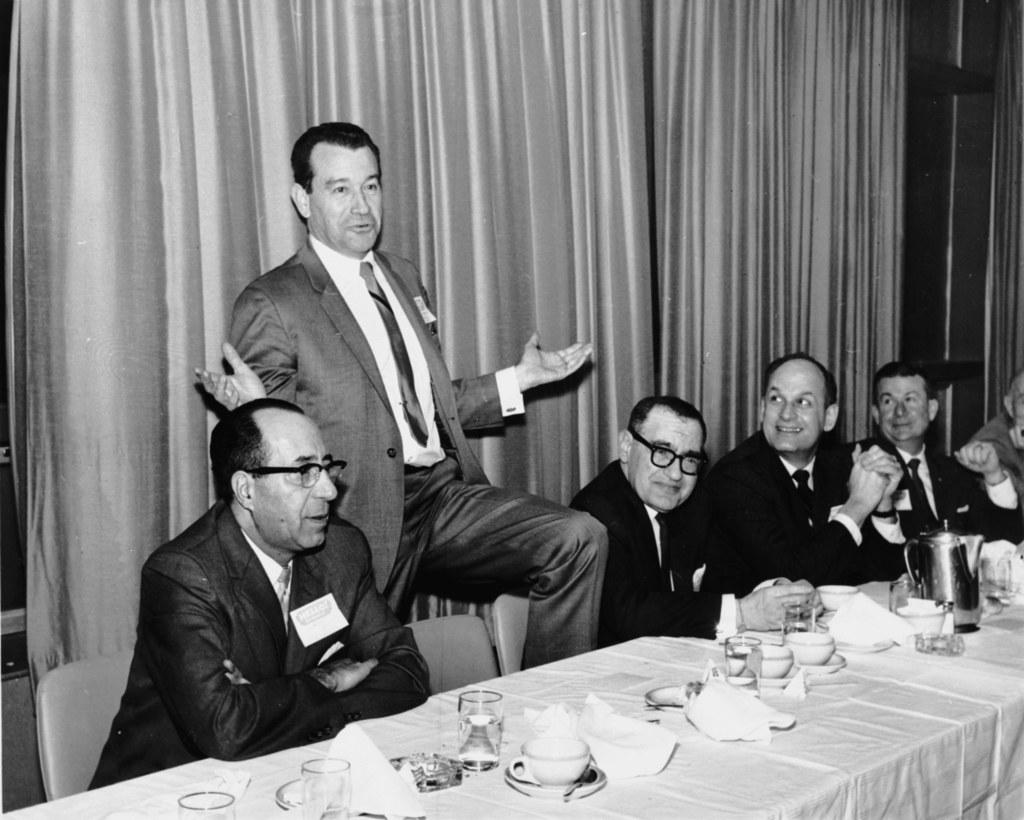What is the position of the person in the image? The person has one leg on a chair in the image. What are the other people in the image doing? There is a group of people sitting in the image. What is in front of the group of people? There is a table in front of the group of people. What type of music is being played in the background of the image? There is no information about music in the image, so it cannot be determined. 